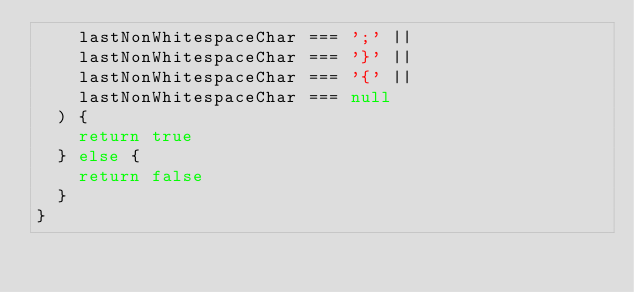Convert code to text. <code><loc_0><loc_0><loc_500><loc_500><_JavaScript_>    lastNonWhitespaceChar === ';' ||
    lastNonWhitespaceChar === '}' ||
    lastNonWhitespaceChar === '{' ||
    lastNonWhitespaceChar === null
  ) {
    return true
  } else {
    return false
  }
}
</code> 